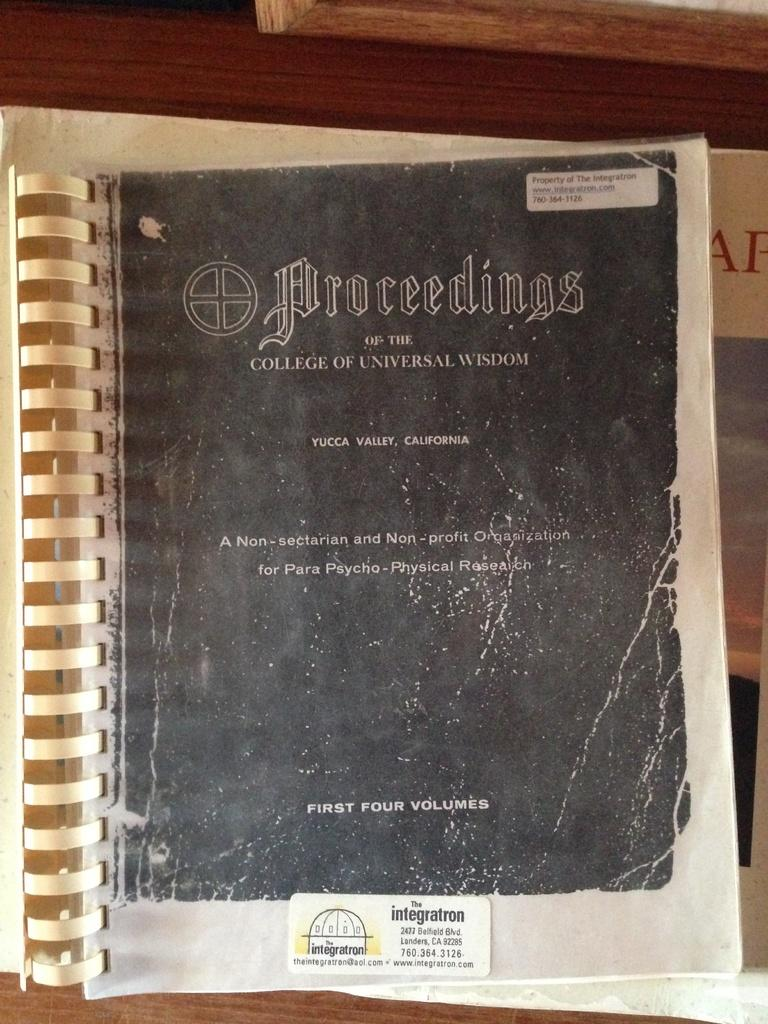<image>
Render a clear and concise summary of the photo. A book of Proceedings of the College of Universal Wisdom for para psycho physical research, including first four volumes. 